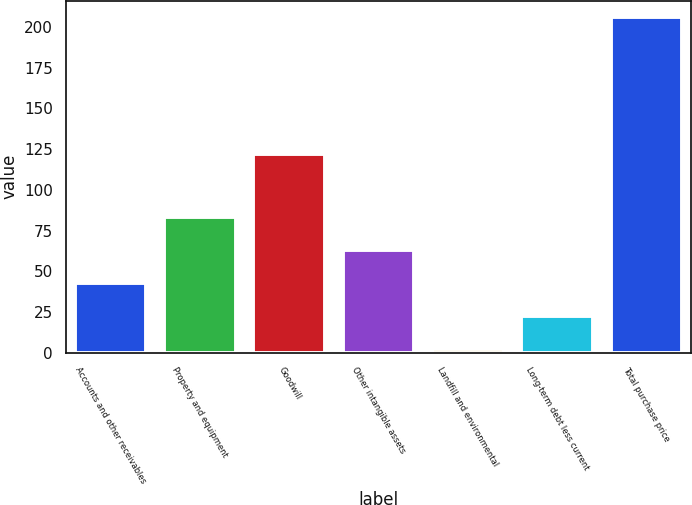<chart> <loc_0><loc_0><loc_500><loc_500><bar_chart><fcel>Accounts and other receivables<fcel>Property and equipment<fcel>Goodwill<fcel>Other intangible assets<fcel>Landfill and environmental<fcel>Long-term debt less current<fcel>Total purchase price<nl><fcel>42.8<fcel>83.6<fcel>122<fcel>63.2<fcel>2<fcel>22.4<fcel>206<nl></chart> 